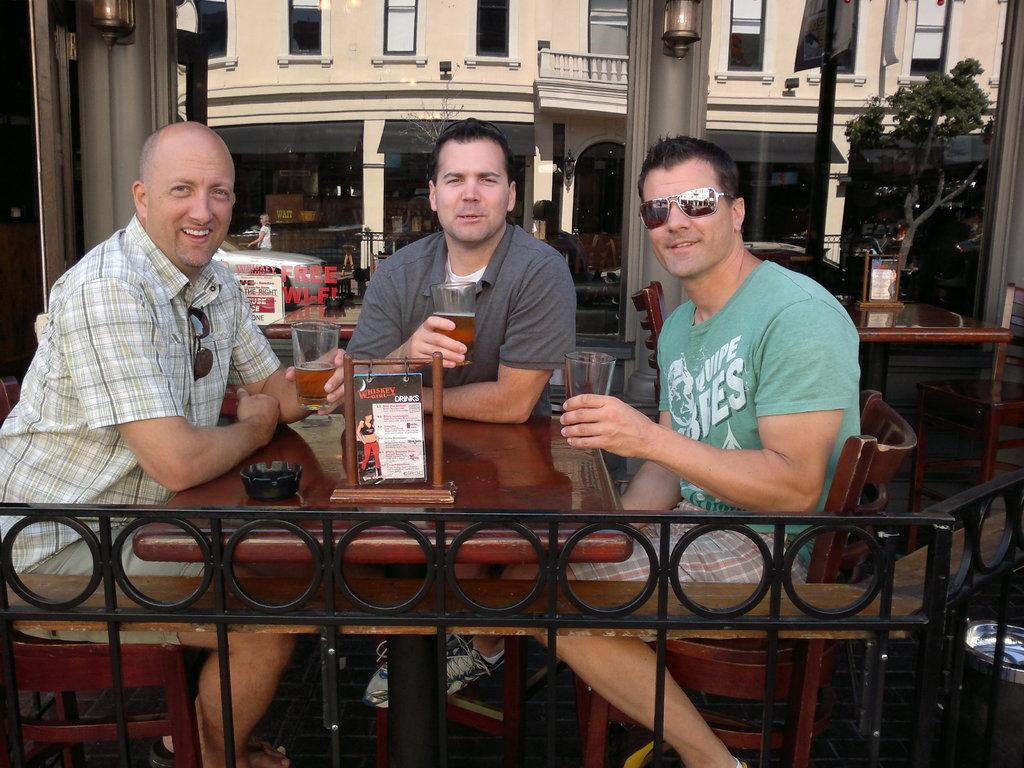How many people are in the image? There are three persons in the image. What are the people doing in the image? The three people are sitting around a table. What are the people holding in the image? Each person is holding a glass. What can be seen in the background of the image? There is a building in the background of the image. What type of root can be seen growing through the table in the image? There is no root growing through the table in the image. Is there any grass visible on the table in the image? No, there is no grass visible on the table in the image. 